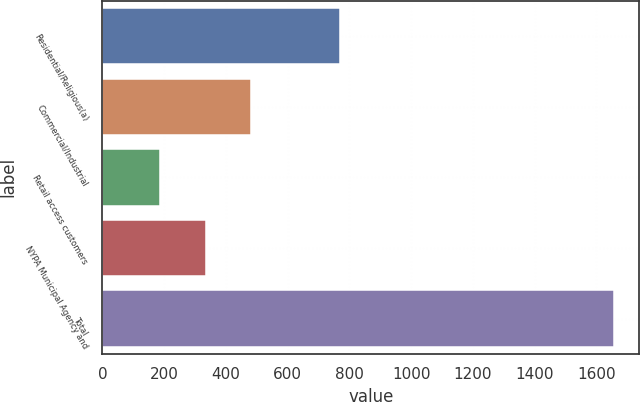<chart> <loc_0><loc_0><loc_500><loc_500><bar_chart><fcel>Residential/Religious(a)<fcel>Commercial/Industrial<fcel>Retail access customers<fcel>NYPA Municipal Agency and<fcel>Total<nl><fcel>768<fcel>481.6<fcel>188<fcel>334.8<fcel>1656<nl></chart> 